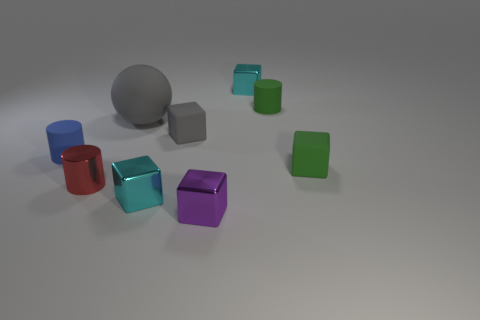Subtract all green cubes. How many cubes are left? 4 Subtract all green blocks. How many blocks are left? 4 Subtract 2 blocks. How many blocks are left? 3 Subtract all yellow cubes. Subtract all green cylinders. How many cubes are left? 5 Add 1 green rubber cylinders. How many objects exist? 10 Subtract all spheres. How many objects are left? 8 Add 9 big gray things. How many big gray things are left? 10 Add 1 tiny brown cubes. How many tiny brown cubes exist? 1 Subtract 0 yellow blocks. How many objects are left? 9 Subtract all small purple things. Subtract all big red cylinders. How many objects are left? 8 